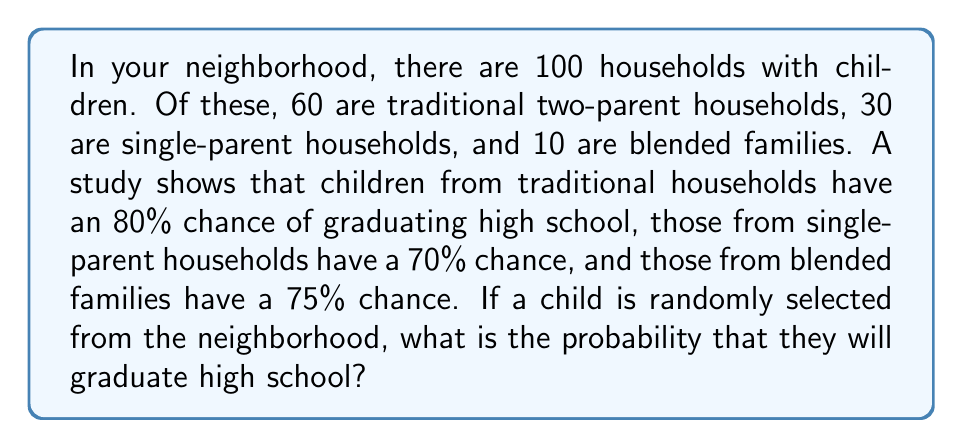Could you help me with this problem? Let's approach this step-by-step using the law of total probability:

1) First, let's define our events:
   A = child graduates high school
   T = child is from a traditional household
   S = child is from a single-parent household
   B = child is from a blended family

2) We're given the following probabilities:
   P(A|T) = 0.80
   P(A|S) = 0.70
   P(A|B) = 0.75

3) We can calculate the probabilities of a child being from each type of household:
   P(T) = 60/100 = 0.60
   P(S) = 30/100 = 0.30
   P(B) = 10/100 = 0.10

4) Now, we can use the law of total probability:
   P(A) = P(A|T) * P(T) + P(A|S) * P(S) + P(A|B) * P(B)

5) Let's substitute our values:
   P(A) = 0.80 * 0.60 + 0.70 * 0.30 + 0.75 * 0.10

6) Now we can calculate:
   P(A) = 0.48 + 0.21 + 0.075 = 0.765

Therefore, the probability that a randomly selected child from the neighborhood will graduate high school is 0.765 or 76.5%.
Answer: $$P(\text{graduation}) = 0.765 \text{ or } 76.5\%$$ 